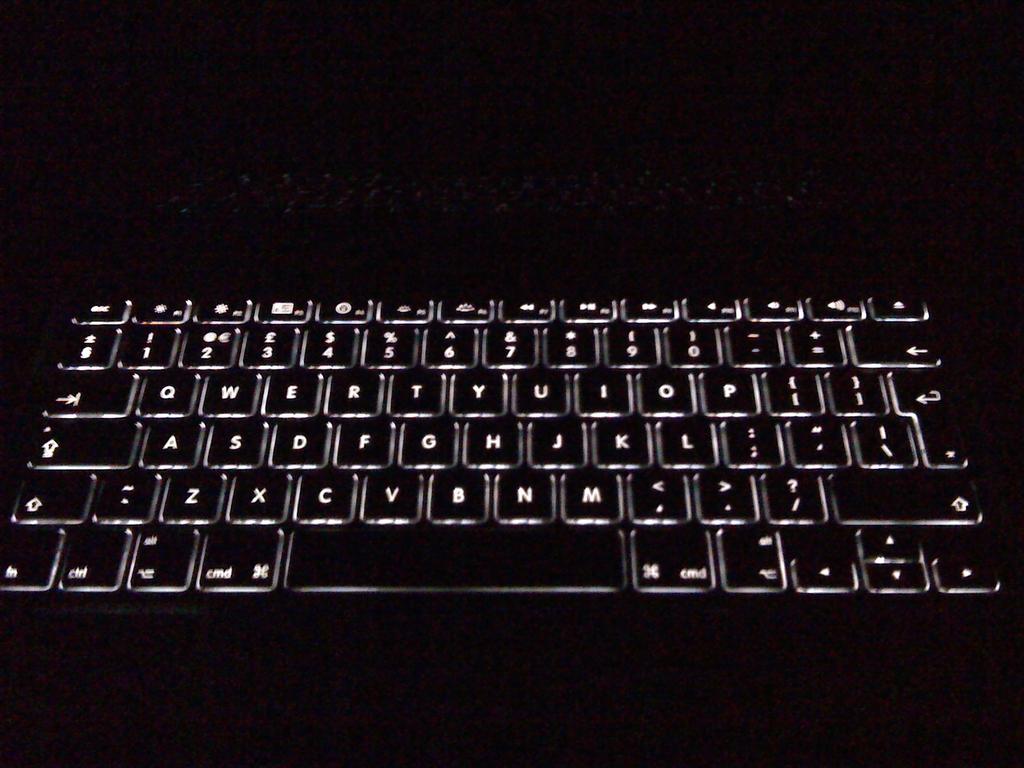What type of interface device is shown?
Provide a succinct answer. Keyboard. What are the letters on the bottle row?
Provide a succinct answer. Zxcvbnm. 